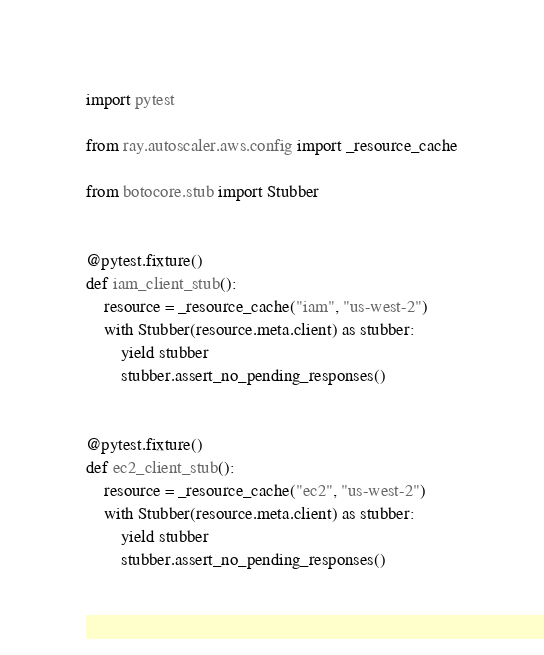<code> <loc_0><loc_0><loc_500><loc_500><_Python_>import pytest

from ray.autoscaler.aws.config import _resource_cache

from botocore.stub import Stubber


@pytest.fixture()
def iam_client_stub():
    resource = _resource_cache("iam", "us-west-2")
    with Stubber(resource.meta.client) as stubber:
        yield stubber
        stubber.assert_no_pending_responses()


@pytest.fixture()
def ec2_client_stub():
    resource = _resource_cache("ec2", "us-west-2")
    with Stubber(resource.meta.client) as stubber:
        yield stubber
        stubber.assert_no_pending_responses()
</code> 